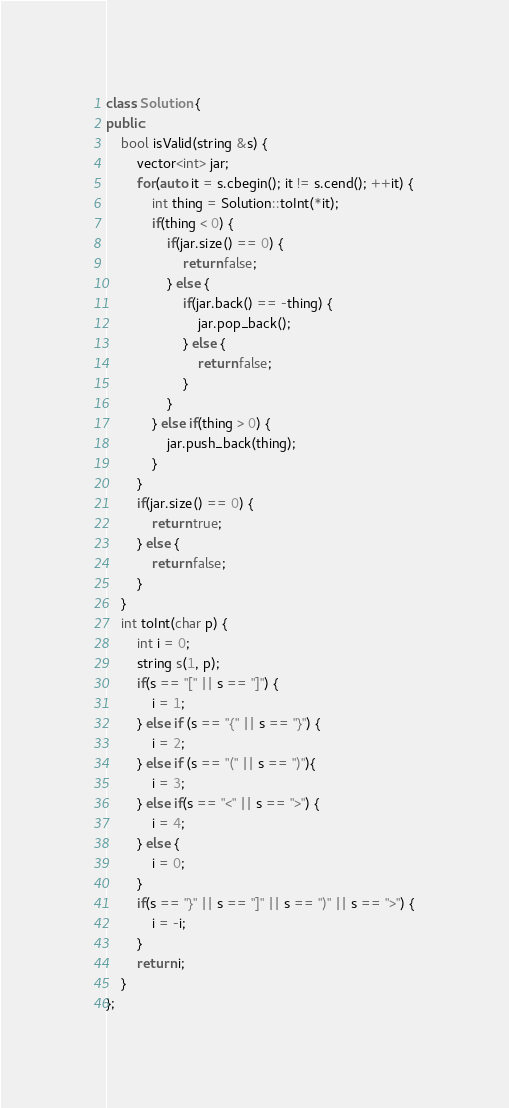Convert code to text. <code><loc_0><loc_0><loc_500><loc_500><_C++_>class Solution {
public:
    bool isValid(string &s) {
        vector<int> jar;
        for(auto it = s.cbegin(); it != s.cend(); ++it) {
            int thing = Solution::toInt(*it);
            if(thing < 0) {
                if(jar.size() == 0) {
                    return false;
                } else {
                    if(jar.back() == -thing) {
                        jar.pop_back();
                    } else {
                        return false;
                    }
                }
            } else if(thing > 0) {
                jar.push_back(thing);
            }
        }
        if(jar.size() == 0) {
            return true;
        } else {
            return false;
        }
    }
    int toInt(char p) {
        int i = 0;
        string s(1, p); 
        if(s == "[" || s == "]") {
            i = 1;
        } else if (s == "{" || s == "}") {
            i = 2;
        } else if (s == "(" || s == ")"){
            i = 3;
        } else if(s == "<" || s == ">") {
            i = 4;
        } else {
            i = 0;
        }
        if(s == "}" || s == "]" || s == ")" || s == ">") {
            i = -i;
        }
        return i;
    }
};</code> 